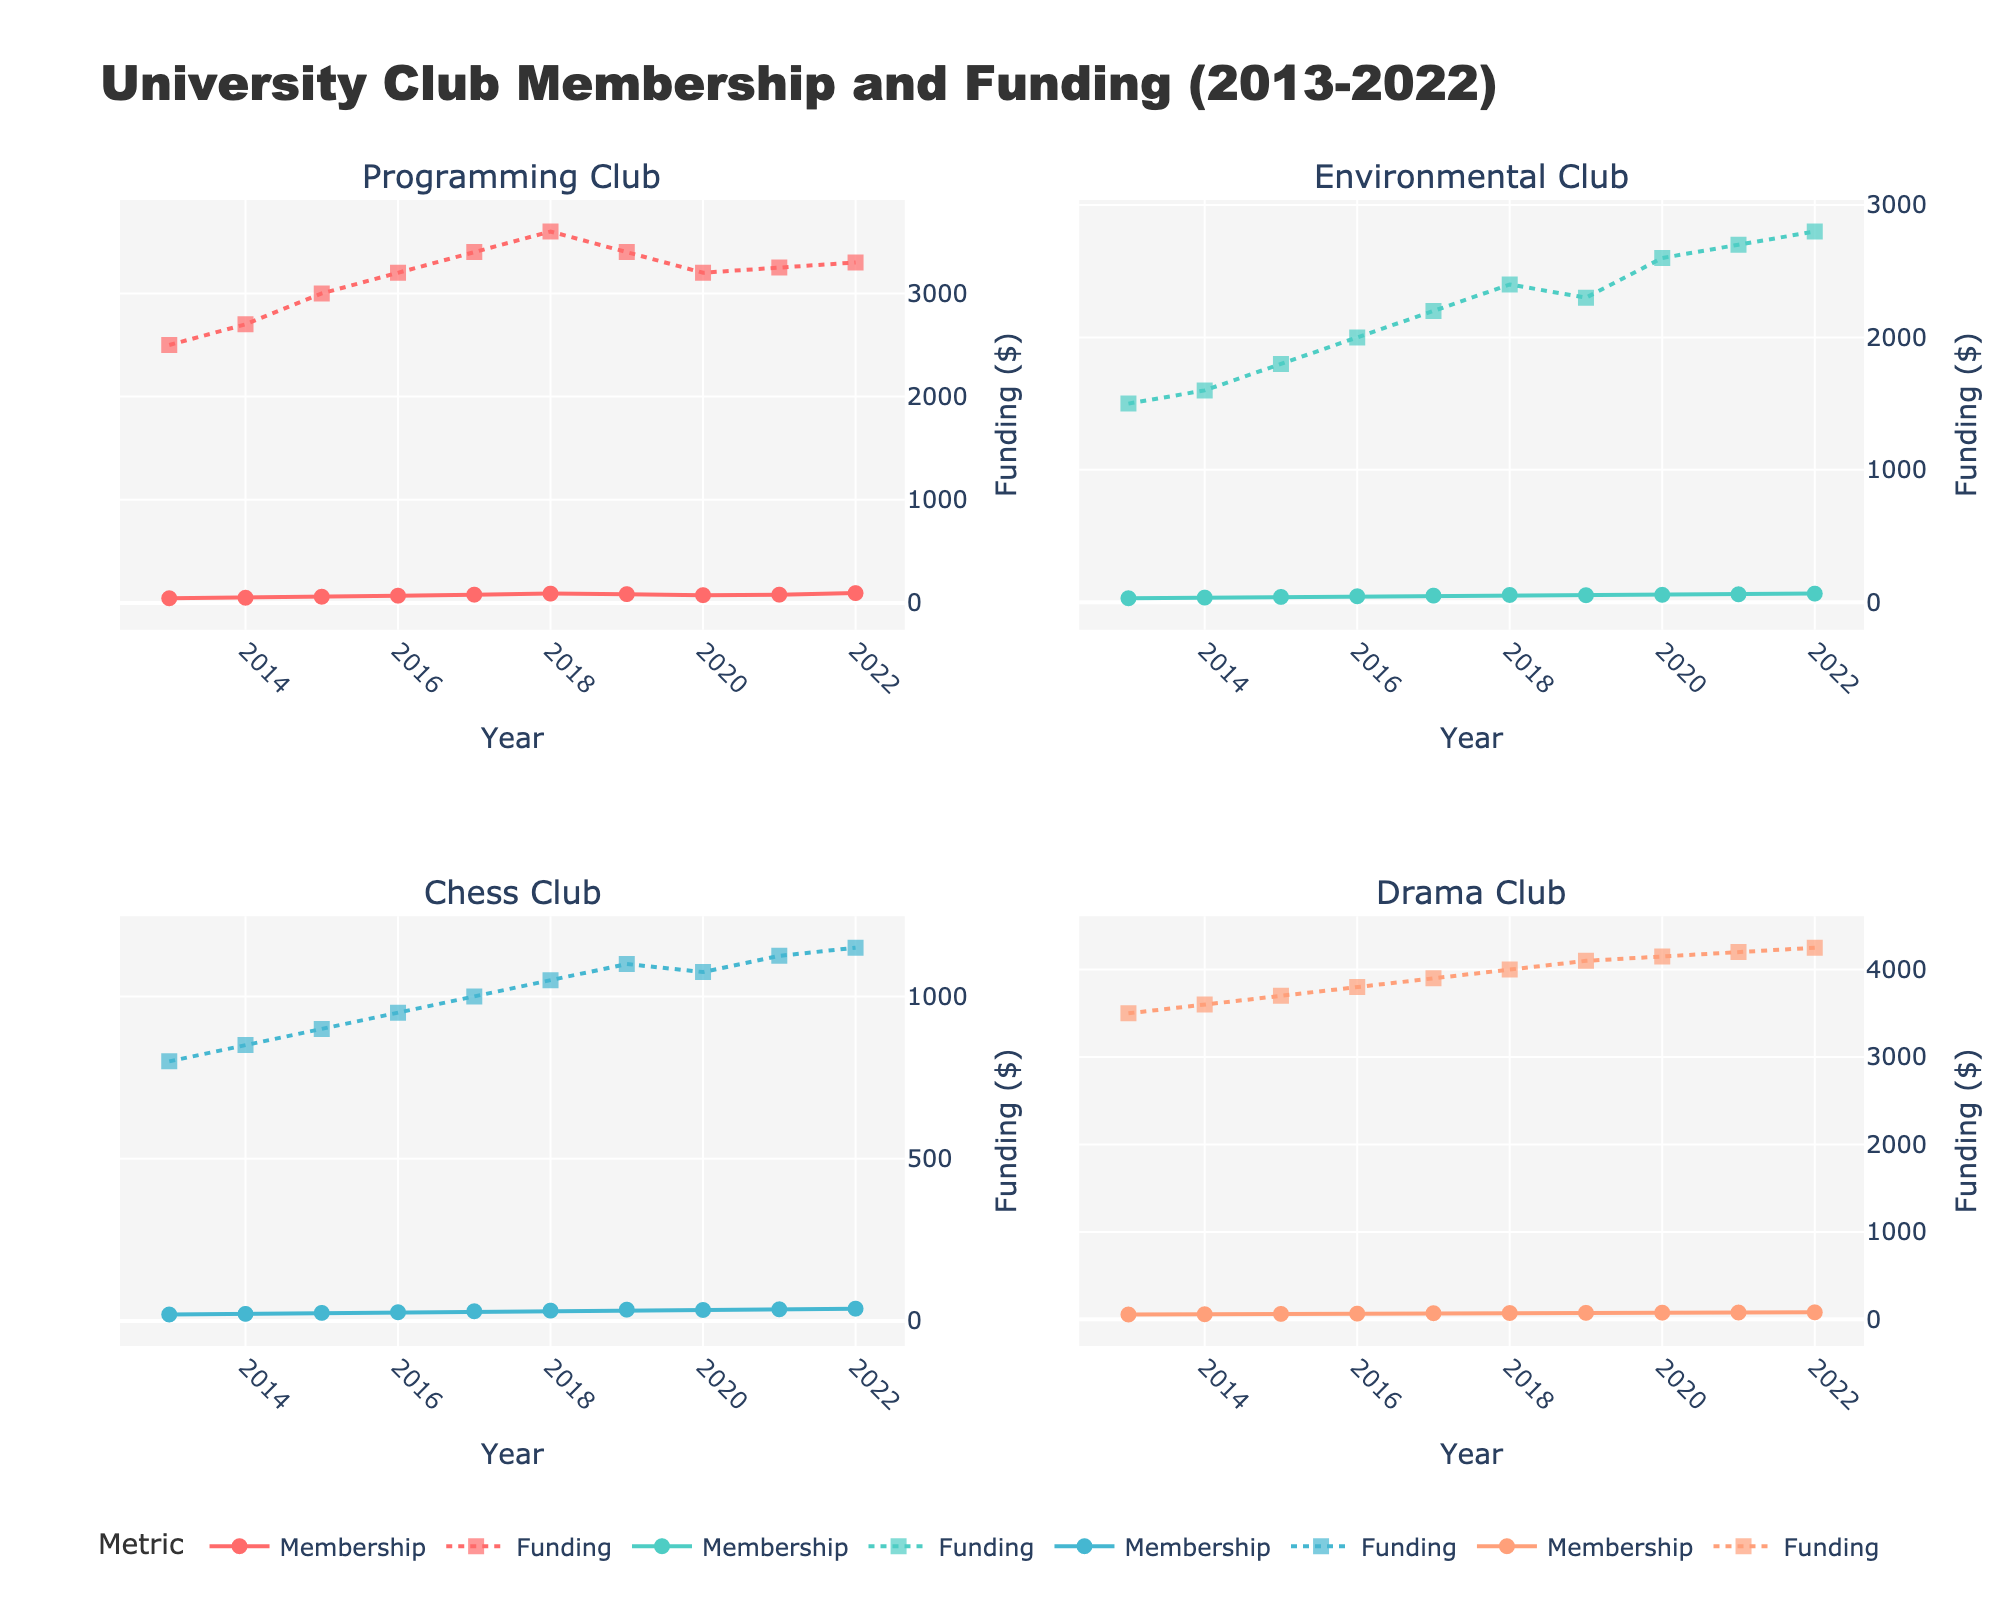What are the subplot titles? The subplot titles are extracted directly from the dataset based on club names. The subplots are titled according to the clubs represented: Programming Club, Environmental Club, Chess Club, and Drama Club.
Answer: Programming Club, Environmental Club, Chess Club, Drama Club How many data points are shown for each club? Each club has data points for each year from 2013 to 2022. Counting these, there are 10 data points per club.
Answer: 10 What is the general trend of membership in the Programming Club over the years? By observing the scatter plot points for membership in the Programming Club, we can see that the number of members generally increases from 45 in 2013 to a peak of 95 in 2022, with some variations along the way.
Answer: Increasing trend Which club had the highest funding in 2022? By looking at the funding levels for each club in 2022 in their respective subplots, the Drama Club's funding is the highest at $4250.
Answer: Drama Club In which year did the Environmental Club experience the highest jump in funding, and what was the difference? To find this, check the difference in funding between consecutive years by looking at the dots representing funding. The highest jump is between 2019 and 2020, from $2300 to $2600, a change of $300.
Answer: 2020, $300 Compare the membership trends for the Drama Club and Chess Club from 2019 to 2022. Analyzing the membership data points from 2019 to 2022, Drama Club membership increased slightly from 74 to 80, while Chess Club membership also increased from 35 to 38, indicating both clubs saw growth, but Drama Club gained more members in absolute terms.
Answer: Both increased, Drama Club gained more What was the funding for the Programming Club in 2015, and how does it compare to its funding in 2020? Referencing the plot, the funding for the Programming Club in 2015 was $3000, and in 2020 it was $3200. The difference is $200.
Answer: $3000 in 2015, $3200 in 2020 Which club had more stable membership trends over the years? Assessing the markers' positions and their changes over time, the Chess Club appears to have the most stable membership trend with gradual increases and fewer fluctuations.
Answer: Chess Club How did the membership of the Environmental Club change between 2013 and 2018? From the plot, membership in the Environmental Club increased gradually from 30 in 2013 to 55 in 2018. This consistent rise indicates a steady growth over these years.
Answer: Increased from 30 to 55 Across all clubs, which one had the highest membership in a single year, and what was the number? Reviewing the highest membership data point across all subplots, the Drama Club had the highest single-year membership in 2022, with 80 members.
Answer: Drama Club, 80 members 